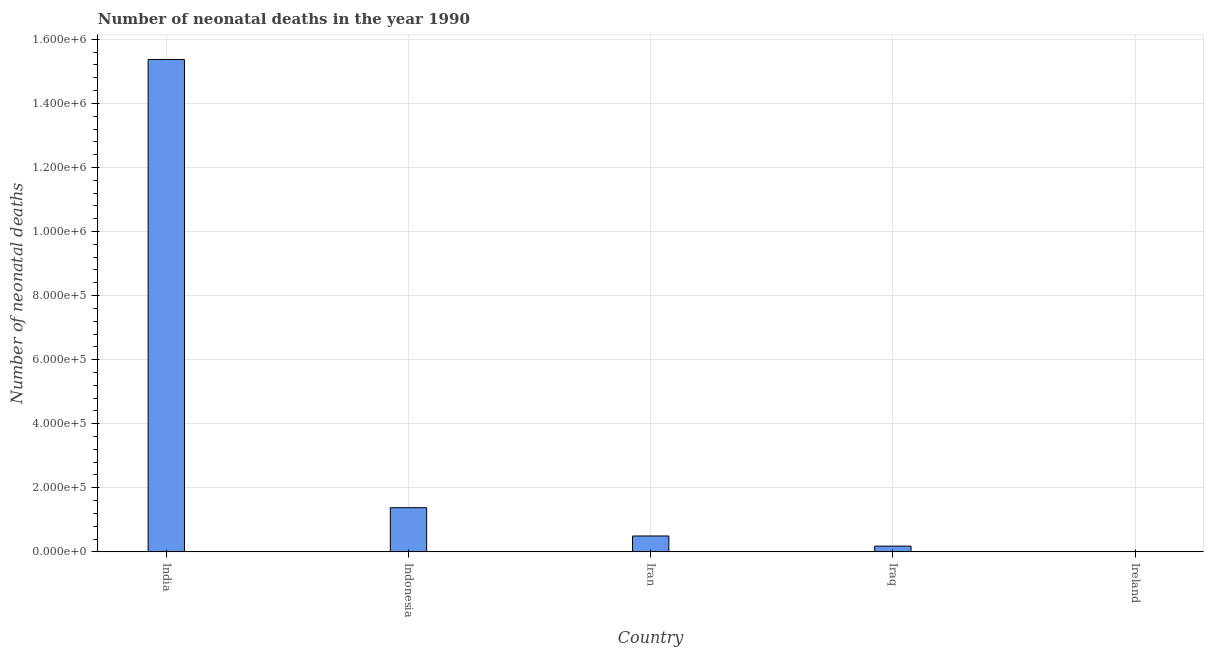Does the graph contain grids?
Your response must be concise. Yes. What is the title of the graph?
Your answer should be very brief. Number of neonatal deaths in the year 1990. What is the label or title of the Y-axis?
Your response must be concise. Number of neonatal deaths. What is the number of neonatal deaths in Ireland?
Provide a succinct answer. 227. Across all countries, what is the maximum number of neonatal deaths?
Keep it short and to the point. 1.54e+06. Across all countries, what is the minimum number of neonatal deaths?
Provide a short and direct response. 227. In which country was the number of neonatal deaths minimum?
Offer a terse response. Ireland. What is the sum of the number of neonatal deaths?
Your answer should be very brief. 1.74e+06. What is the difference between the number of neonatal deaths in India and Ireland?
Your response must be concise. 1.54e+06. What is the average number of neonatal deaths per country?
Ensure brevity in your answer.  3.49e+05. What is the median number of neonatal deaths?
Provide a short and direct response. 4.96e+04. In how many countries, is the number of neonatal deaths greater than 1400000 ?
Ensure brevity in your answer.  1. What is the ratio of the number of neonatal deaths in Iraq to that in Ireland?
Ensure brevity in your answer.  79.01. Is the number of neonatal deaths in Indonesia less than that in Iran?
Provide a succinct answer. No. Is the difference between the number of neonatal deaths in Iran and Ireland greater than the difference between any two countries?
Provide a short and direct response. No. What is the difference between the highest and the second highest number of neonatal deaths?
Offer a terse response. 1.40e+06. What is the difference between the highest and the lowest number of neonatal deaths?
Keep it short and to the point. 1.54e+06. In how many countries, is the number of neonatal deaths greater than the average number of neonatal deaths taken over all countries?
Your response must be concise. 1. How many bars are there?
Offer a very short reply. 5. What is the difference between two consecutive major ticks on the Y-axis?
Provide a short and direct response. 2.00e+05. What is the Number of neonatal deaths in India?
Your answer should be compact. 1.54e+06. What is the Number of neonatal deaths of Indonesia?
Offer a very short reply. 1.38e+05. What is the Number of neonatal deaths in Iran?
Your answer should be very brief. 4.96e+04. What is the Number of neonatal deaths of Iraq?
Offer a terse response. 1.79e+04. What is the Number of neonatal deaths of Ireland?
Offer a terse response. 227. What is the difference between the Number of neonatal deaths in India and Indonesia?
Ensure brevity in your answer.  1.40e+06. What is the difference between the Number of neonatal deaths in India and Iran?
Give a very brief answer. 1.49e+06. What is the difference between the Number of neonatal deaths in India and Iraq?
Provide a short and direct response. 1.52e+06. What is the difference between the Number of neonatal deaths in India and Ireland?
Keep it short and to the point. 1.54e+06. What is the difference between the Number of neonatal deaths in Indonesia and Iran?
Your answer should be compact. 8.83e+04. What is the difference between the Number of neonatal deaths in Indonesia and Iraq?
Your response must be concise. 1.20e+05. What is the difference between the Number of neonatal deaths in Indonesia and Ireland?
Keep it short and to the point. 1.38e+05. What is the difference between the Number of neonatal deaths in Iran and Iraq?
Ensure brevity in your answer.  3.17e+04. What is the difference between the Number of neonatal deaths in Iran and Ireland?
Your response must be concise. 4.94e+04. What is the difference between the Number of neonatal deaths in Iraq and Ireland?
Your answer should be compact. 1.77e+04. What is the ratio of the Number of neonatal deaths in India to that in Indonesia?
Your answer should be very brief. 11.15. What is the ratio of the Number of neonatal deaths in India to that in Iran?
Give a very brief answer. 30.98. What is the ratio of the Number of neonatal deaths in India to that in Iraq?
Provide a short and direct response. 85.69. What is the ratio of the Number of neonatal deaths in India to that in Ireland?
Offer a terse response. 6770.96. What is the ratio of the Number of neonatal deaths in Indonesia to that in Iran?
Offer a very short reply. 2.78. What is the ratio of the Number of neonatal deaths in Indonesia to that in Iraq?
Your answer should be very brief. 7.69. What is the ratio of the Number of neonatal deaths in Indonesia to that in Ireland?
Provide a short and direct response. 607.44. What is the ratio of the Number of neonatal deaths in Iran to that in Iraq?
Provide a succinct answer. 2.77. What is the ratio of the Number of neonatal deaths in Iran to that in Ireland?
Give a very brief answer. 218.55. What is the ratio of the Number of neonatal deaths in Iraq to that in Ireland?
Your answer should be very brief. 79.01. 